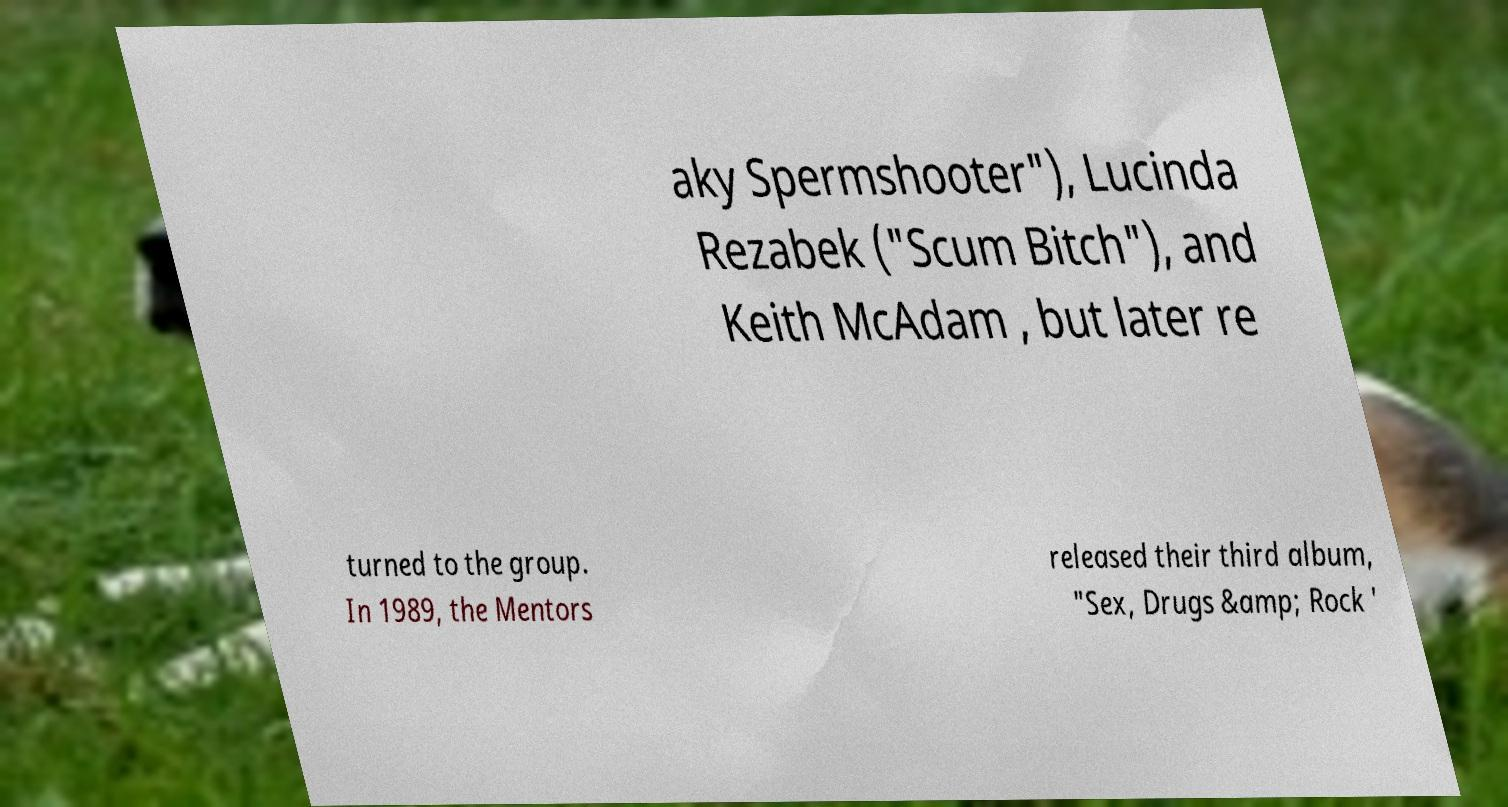Could you extract and type out the text from this image? aky Spermshooter"), Lucinda Rezabek ("Scum Bitch"), and Keith McAdam , but later re turned to the group. In 1989, the Mentors released their third album, "Sex, Drugs &amp; Rock ' 